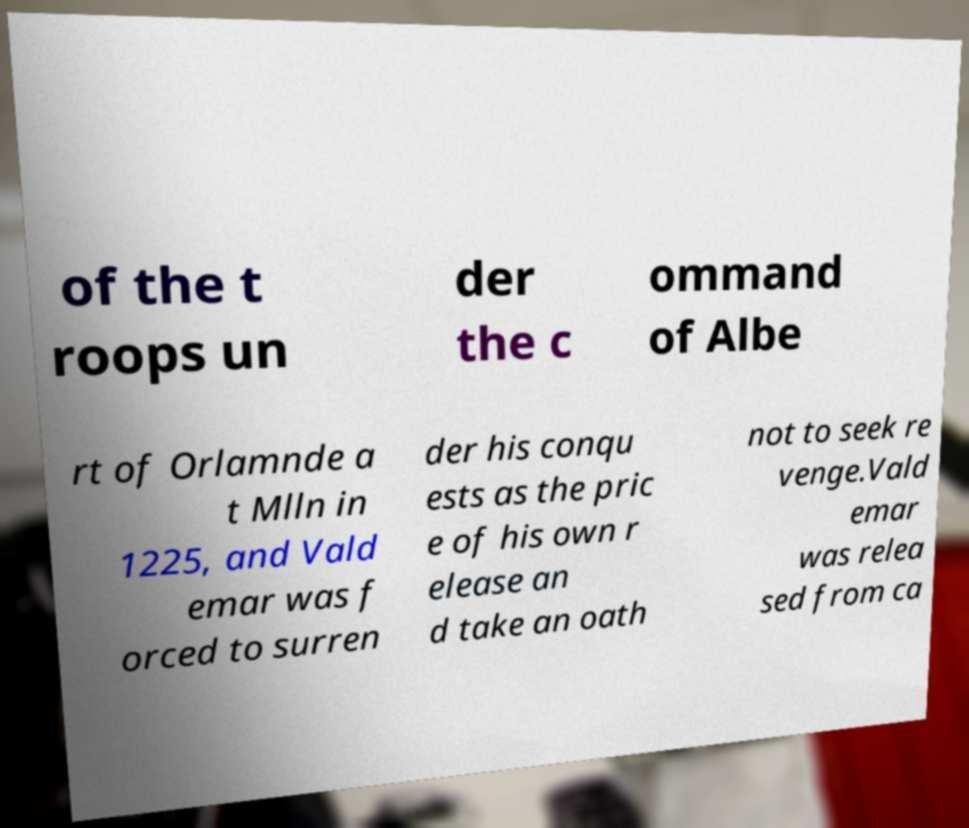Can you accurately transcribe the text from the provided image for me? of the t roops un der the c ommand of Albe rt of Orlamnde a t Mlln in 1225, and Vald emar was f orced to surren der his conqu ests as the pric e of his own r elease an d take an oath not to seek re venge.Vald emar was relea sed from ca 